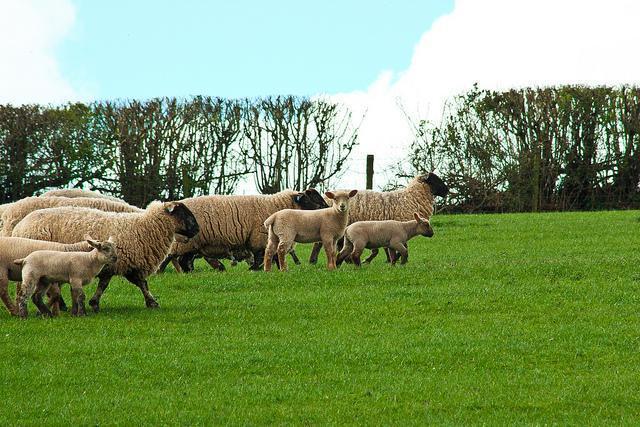How many sheep have blackheads?
Give a very brief answer. 3. How many sheep are visible?
Give a very brief answer. 7. 